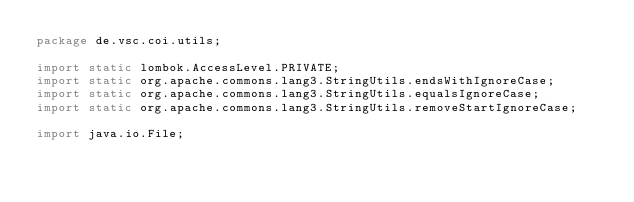<code> <loc_0><loc_0><loc_500><loc_500><_Java_>package de.vsc.coi.utils;

import static lombok.AccessLevel.PRIVATE;
import static org.apache.commons.lang3.StringUtils.endsWithIgnoreCase;
import static org.apache.commons.lang3.StringUtils.equalsIgnoreCase;
import static org.apache.commons.lang3.StringUtils.removeStartIgnoreCase;

import java.io.File;</code> 